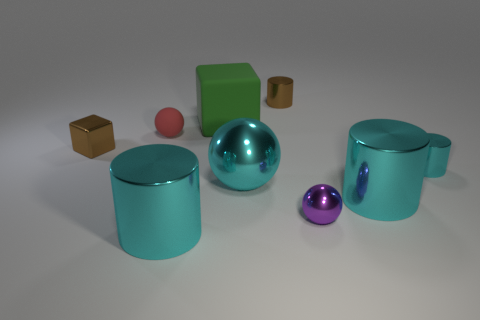Subtract all gray cubes. How many cyan cylinders are left? 3 Subtract all blocks. How many objects are left? 7 Subtract 0 red cubes. How many objects are left? 9 Subtract all tiny brown shiny cylinders. Subtract all cyan spheres. How many objects are left? 7 Add 4 small brown metallic things. How many small brown metallic things are left? 6 Add 2 green things. How many green things exist? 3 